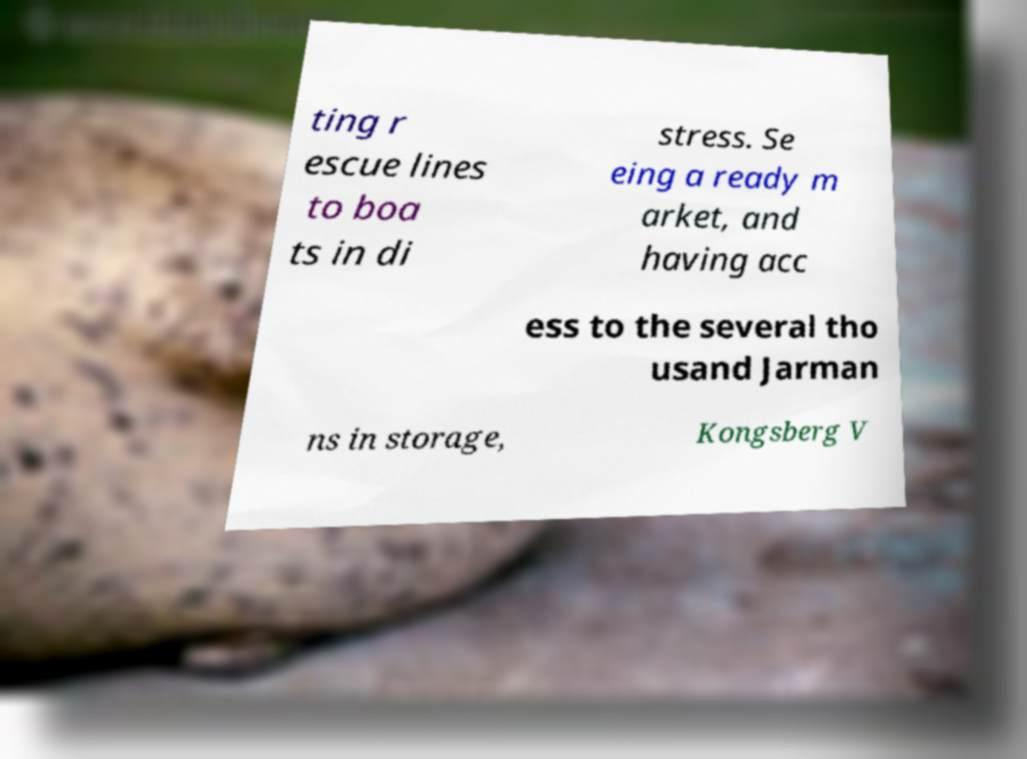Could you assist in decoding the text presented in this image and type it out clearly? ting r escue lines to boa ts in di stress. Se eing a ready m arket, and having acc ess to the several tho usand Jarman ns in storage, Kongsberg V 